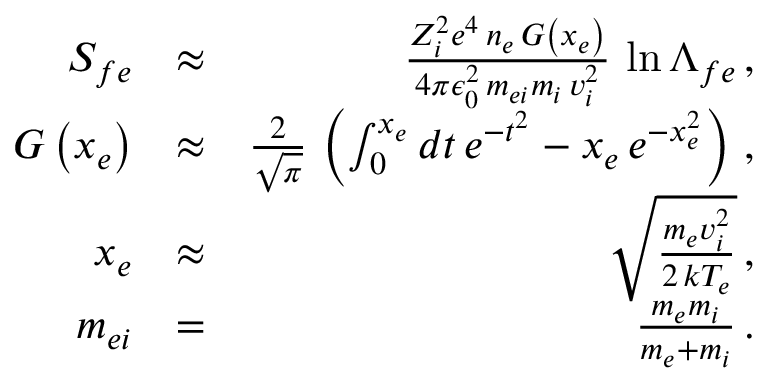<formula> <loc_0><loc_0><loc_500><loc_500>\begin{array} { r l r } { S _ { f e } } & { \approx } & { \frac { Z _ { i } ^ { 2 } e ^ { 4 } \, n _ { e } \, G \left ( x _ { e } \right ) } { 4 \pi \epsilon _ { 0 } ^ { 2 } \, m _ { e i } m _ { i } \, v _ { i } ^ { 2 } } \, \ln \Lambda _ { f e } \, , } \\ { G \left ( x _ { e } \right ) } & { \approx } & { \frac { 2 } { \sqrt { \pi } } \, \left ( \int _ { 0 } ^ { x _ { e } } d t \, e ^ { - t ^ { 2 } } - x _ { e } \, e ^ { - x _ { e } ^ { 2 } } \right ) \, , } \\ { x _ { e } } & { \approx } & { \sqrt { \frac { m _ { e } v _ { i } ^ { 2 } } { 2 \, k T _ { e } } } \, , } \\ { m _ { e i } } & { = } & { \frac { m _ { e } m _ { i } } { m _ { e } + m _ { i } } \, . } \end{array}</formula> 